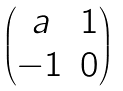<formula> <loc_0><loc_0><loc_500><loc_500>\begin{pmatrix} a & 1 \\ - 1 & 0 \end{pmatrix}</formula> 